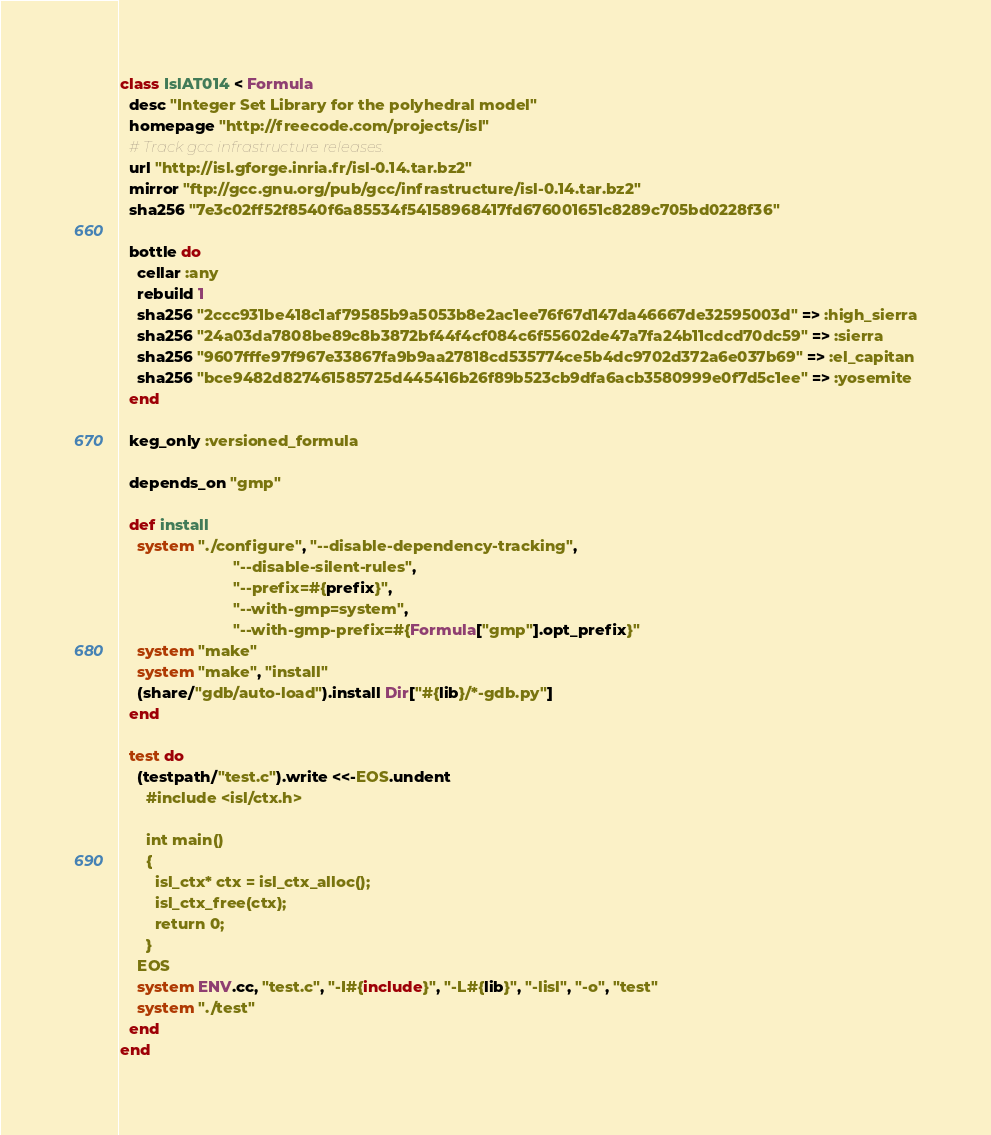Convert code to text. <code><loc_0><loc_0><loc_500><loc_500><_Ruby_>class IslAT014 < Formula
  desc "Integer Set Library for the polyhedral model"
  homepage "http://freecode.com/projects/isl"
  # Track gcc infrastructure releases.
  url "http://isl.gforge.inria.fr/isl-0.14.tar.bz2"
  mirror "ftp://gcc.gnu.org/pub/gcc/infrastructure/isl-0.14.tar.bz2"
  sha256 "7e3c02ff52f8540f6a85534f54158968417fd676001651c8289c705bd0228f36"

  bottle do
    cellar :any
    rebuild 1
    sha256 "2ccc931be418c1af79585b9a5053b8e2ac1ee76f67d147da46667de32595003d" => :high_sierra
    sha256 "24a03da7808be89c8b3872bf44f4cf084c6f55602de47a7fa24b11cdcd70dc59" => :sierra
    sha256 "9607fffe97f967e33867fa9b9aa27818cd535774ce5b4dc9702d372a6e037b69" => :el_capitan
    sha256 "bce9482d827461585725d445416b26f89b523cb9dfa6acb3580999e0f7d5c1ee" => :yosemite
  end

  keg_only :versioned_formula

  depends_on "gmp"

  def install
    system "./configure", "--disable-dependency-tracking",
                          "--disable-silent-rules",
                          "--prefix=#{prefix}",
                          "--with-gmp=system",
                          "--with-gmp-prefix=#{Formula["gmp"].opt_prefix}"
    system "make"
    system "make", "install"
    (share/"gdb/auto-load").install Dir["#{lib}/*-gdb.py"]
  end

  test do
    (testpath/"test.c").write <<-EOS.undent
      #include <isl/ctx.h>

      int main()
      {
        isl_ctx* ctx = isl_ctx_alloc();
        isl_ctx_free(ctx);
        return 0;
      }
    EOS
    system ENV.cc, "test.c", "-I#{include}", "-L#{lib}", "-lisl", "-o", "test"
    system "./test"
  end
end
</code> 